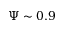Convert formula to latex. <formula><loc_0><loc_0><loc_500><loc_500>\Psi \sim 0 . 9</formula> 